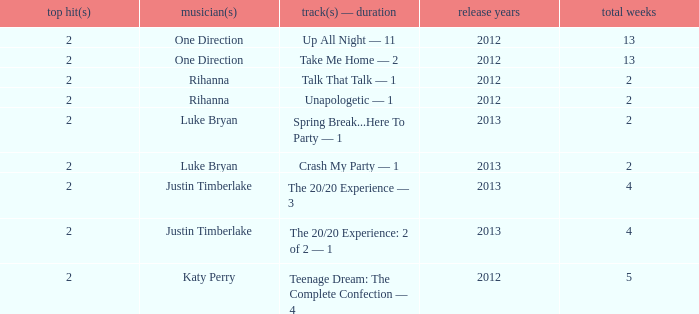What is the title of every song, and how many weeks was each song at #1 for Rihanna in 2012? Talk That Talk — 1, Unapologetic — 1. 